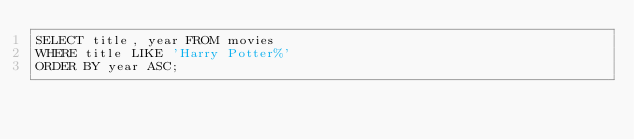<code> <loc_0><loc_0><loc_500><loc_500><_SQL_>SELECT title, year FROM movies
WHERE title LIKE 'Harry Potter%'
ORDER BY year ASC;</code> 